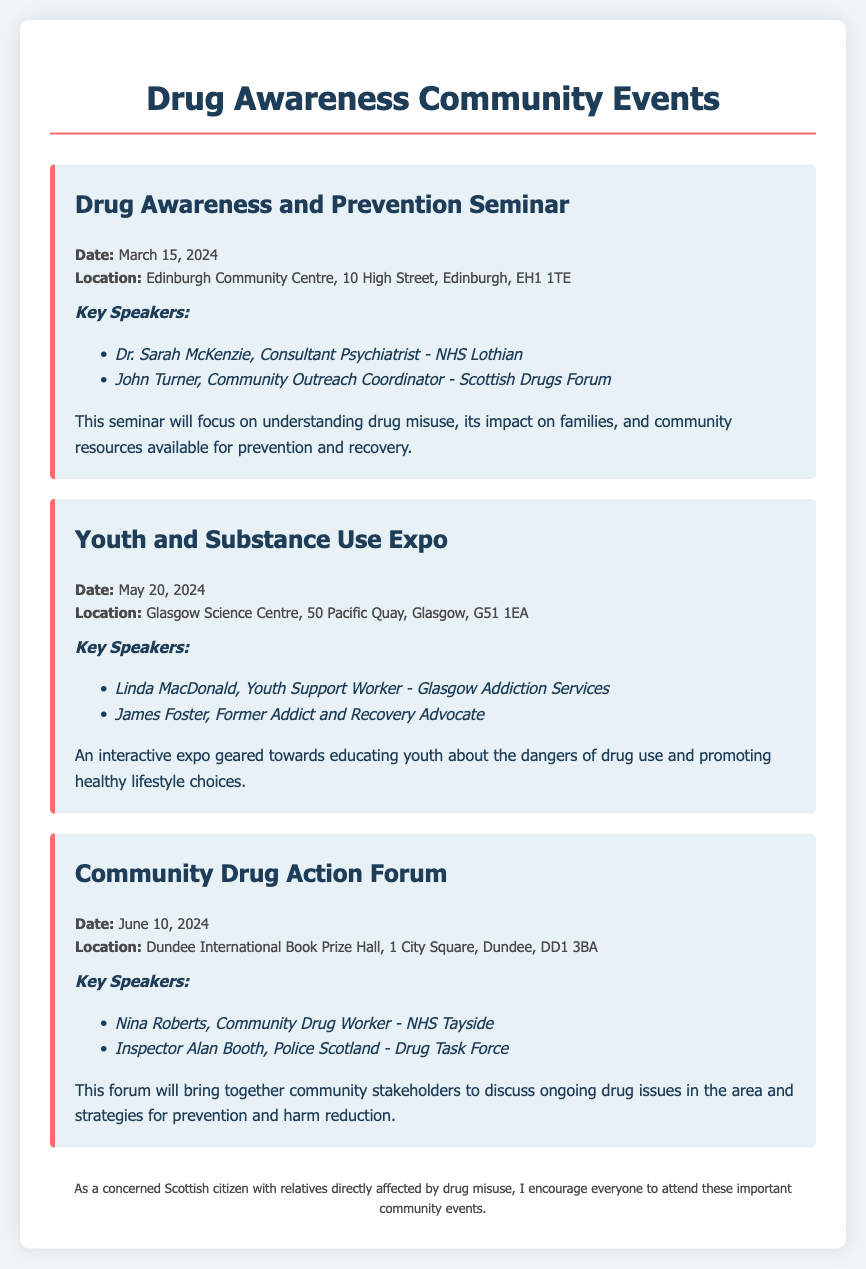what is the date of the Drug Awareness and Prevention Seminar? The date of the event is mentioned directly in the event details section of the document.
Answer: March 15, 2024 where is the Youth and Substance Use Expo taking place? The location of the event is specified in the event details and indicates the venue with the address.
Answer: Glasgow Science Centre, 50 Pacific Quay, Glasgow, G51 1EA who is a key speaker at the Community Drug Action Forum? The key speakers are listed in each event section, highlighting their roles.
Answer: Nina Roberts, Community Drug Worker - NHS Tayside how many events are listed in the document? The document includes a total of three events, as indicated by the individual event sections presented in the resume.
Answer: Three what is the focus of the Youth and Substance Use Expo? The expo's main purpose is summarized in its description, showcasing its educational goal.
Answer: Educating youth about the dangers of drug use what type of event is scheduled for June 10, 2024? This question asks about the nature of the event identified by its name and date.
Answer: Community Drug Action Forum who will speak about community resources available for prevention and recovery? This involves understanding the roles of the speakers mentioned in the seminar description.
Answer: Dr. Sarah McKenzie, Consultant Psychiatrist - NHS Lothian what is the main aim of the Drug Awareness and Prevention Seminar? The document provides a description of the seminar, clearly stating its foundational aim.
Answer: Understanding drug misuse and its impact on families 